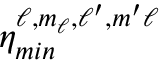<formula> <loc_0><loc_0><loc_500><loc_500>\eta _ { \min } ^ { \ell , m _ { \ell } , \ell ^ { \prime } , m ^ { \prime } \ell }</formula> 